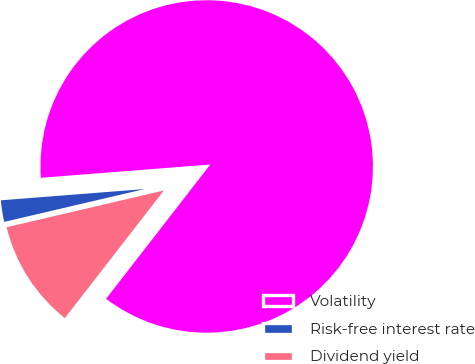Convert chart. <chart><loc_0><loc_0><loc_500><loc_500><pie_chart><fcel>Volatility<fcel>Risk-free interest rate<fcel>Dividend yield<nl><fcel>86.75%<fcel>2.41%<fcel>10.84%<nl></chart> 